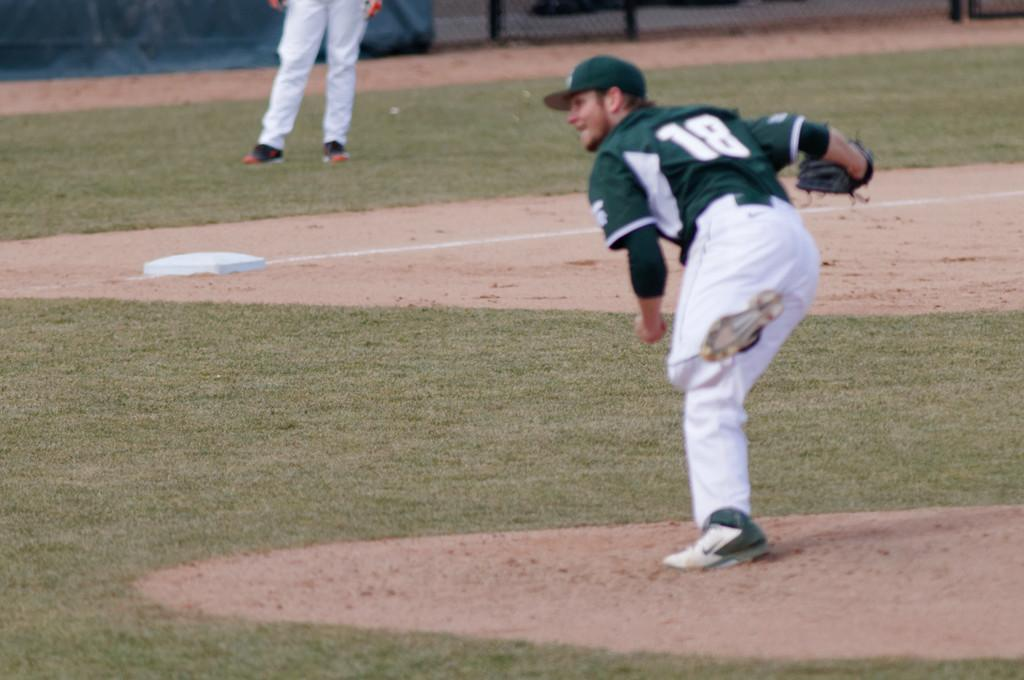What type of vegetation is present in the image? There is grass in the image. What type of structure can be seen in the image? There is a fence in the image. How many people are in the image? There are two persons in the image. What is the man in the front wearing on his head? The man in the front is wearing a green hat. What is the man in the front wearing on his upper body? The man in the front is wearing a green shirt. What does the fireman compare in the image? There is no fireman present in the image, so it is not possible to answer that question. 